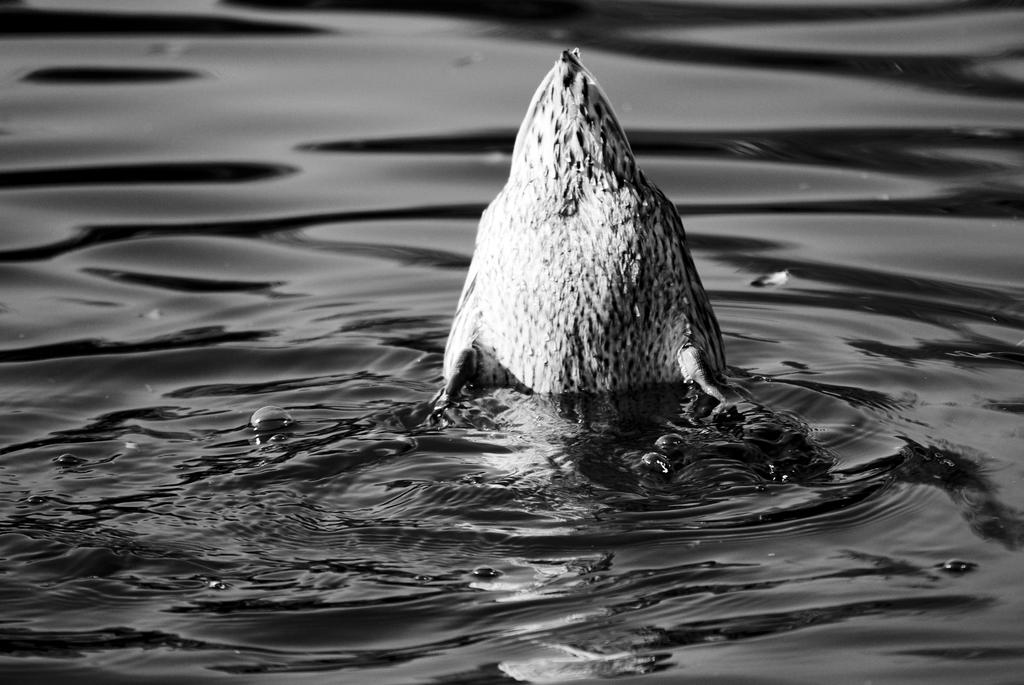What is the color scheme of the image? The image is black and white. What animal can be seen in the image? There is a bird in the image. Where is the bird located in the image? The bird is in the water and in the center of the image. What type of silk fabric is draped over the bird in the image? There is no silk fabric present in the image; it features a bird in the water. How many cats can be seen interacting with the bird in the image? There are no cats present in the image; it only features a bird in the water. 